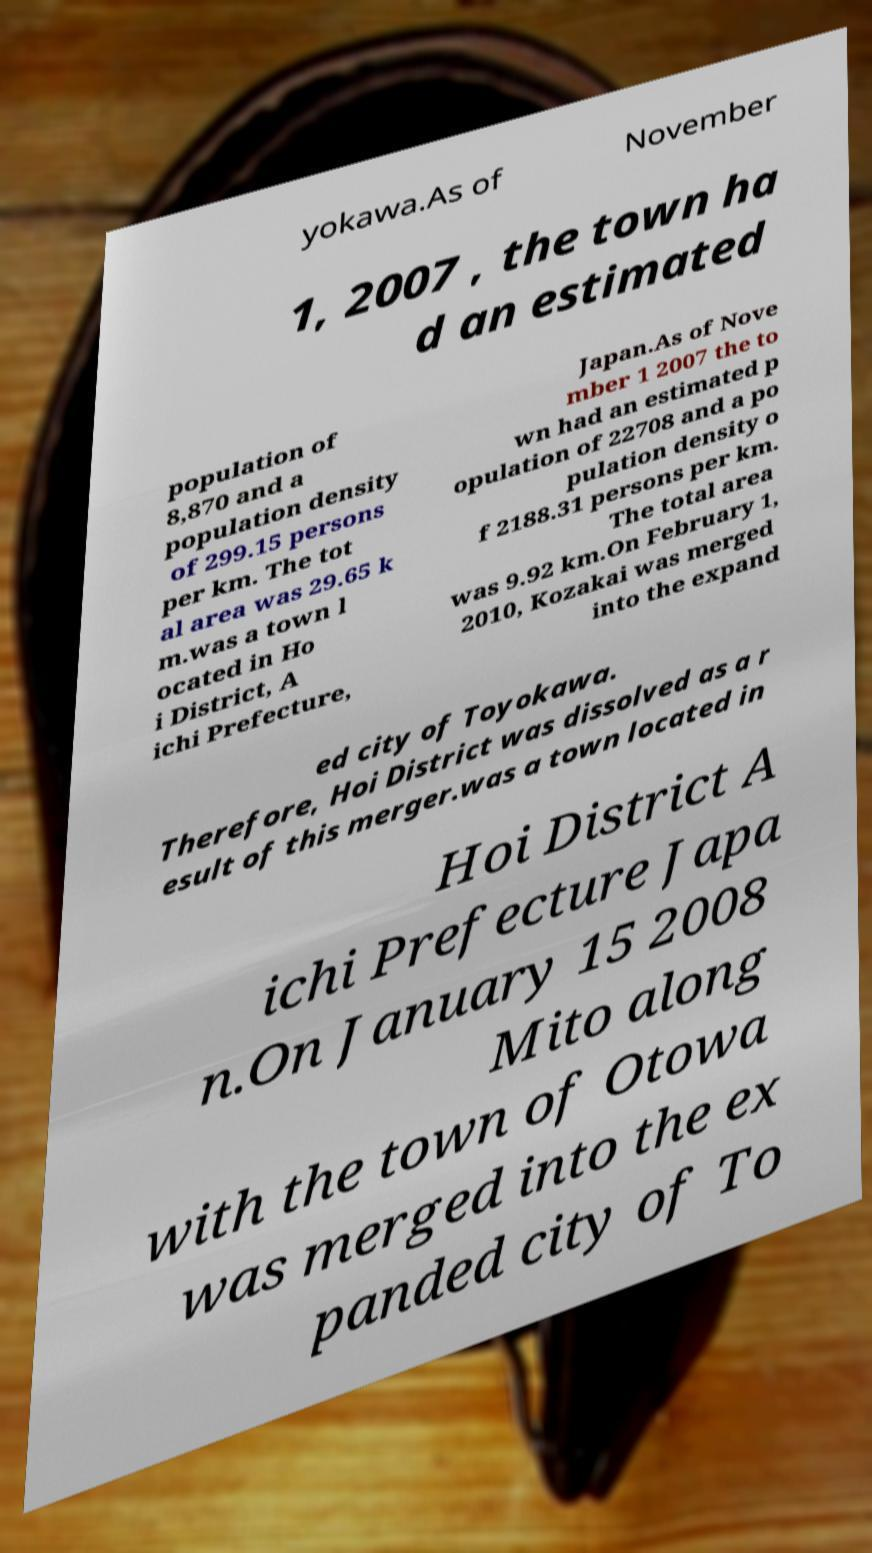Can you read and provide the text displayed in the image?This photo seems to have some interesting text. Can you extract and type it out for me? yokawa.As of November 1, 2007 , the town ha d an estimated population of 8,870 and a population density of 299.15 persons per km. The tot al area was 29.65 k m.was a town l ocated in Ho i District, A ichi Prefecture, Japan.As of Nove mber 1 2007 the to wn had an estimated p opulation of 22708 and a po pulation density o f 2188.31 persons per km. The total area was 9.92 km.On February 1, 2010, Kozakai was merged into the expand ed city of Toyokawa. Therefore, Hoi District was dissolved as a r esult of this merger.was a town located in Hoi District A ichi Prefecture Japa n.On January 15 2008 Mito along with the town of Otowa was merged into the ex panded city of To 